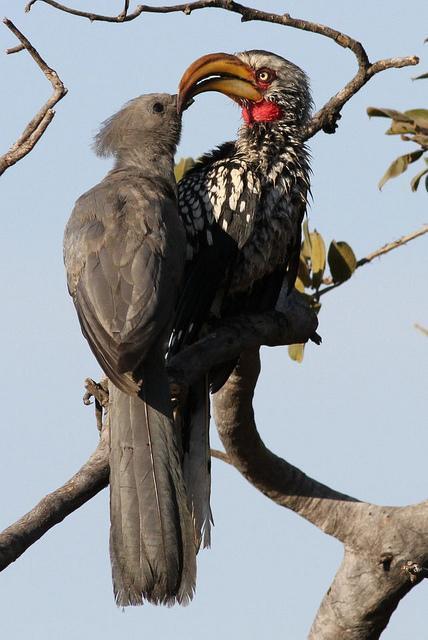How many birds are there?
Give a very brief answer. 2. 